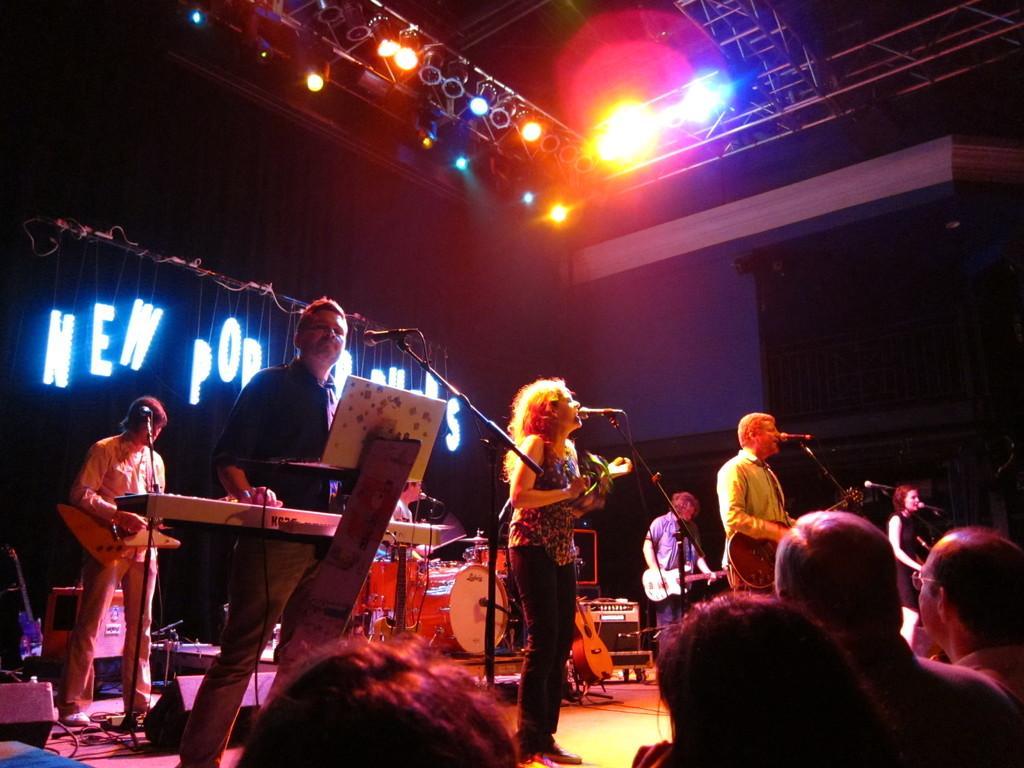Please provide a concise description of this image. In this image there are group of persons who are playing musical instruments on the stage at the right side of the image there are some persons who are watching the show at the top of the image there are some lights. 